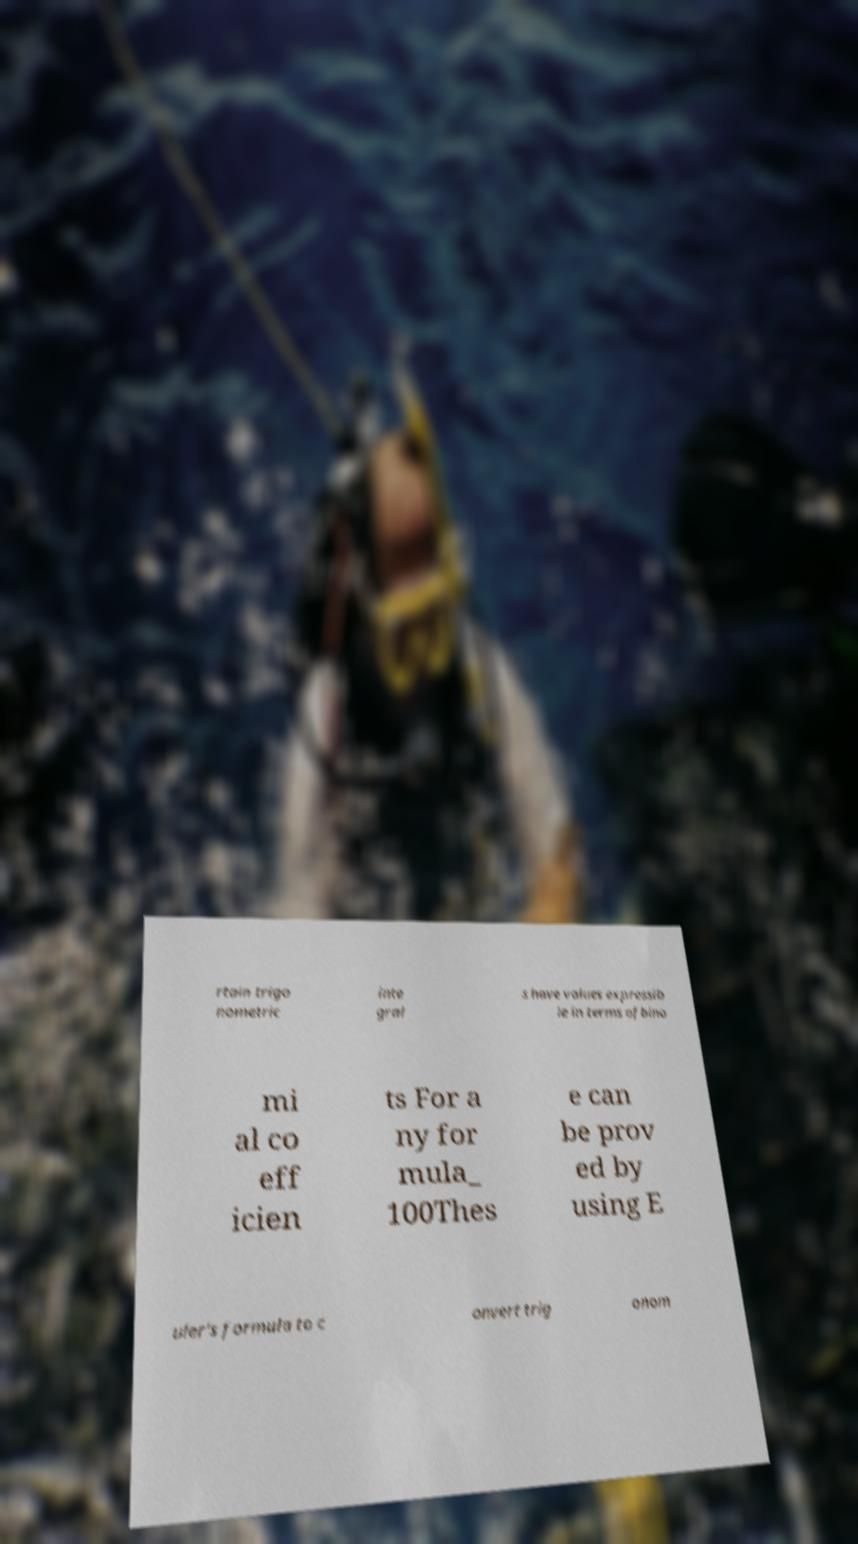Can you read and provide the text displayed in the image?This photo seems to have some interesting text. Can you extract and type it out for me? rtain trigo nometric inte gral s have values expressib le in terms ofbino mi al co eff icien ts For a ny for mula_ 100Thes e can be prov ed by using E uler's formula to c onvert trig onom 